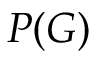Convert formula to latex. <formula><loc_0><loc_0><loc_500><loc_500>P ( G )</formula> 